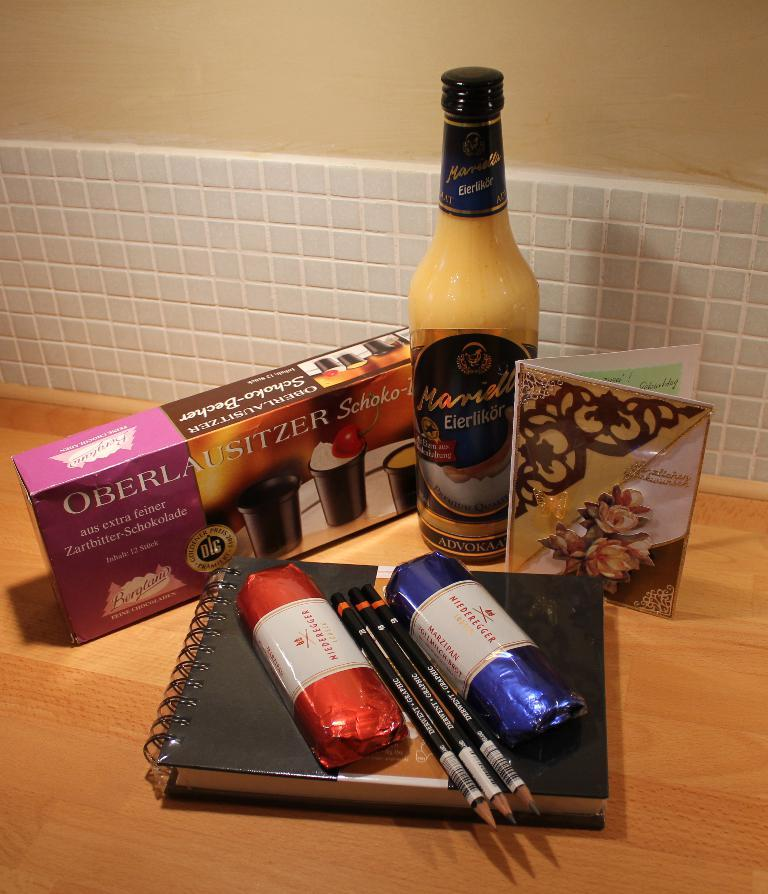<image>
Create a compact narrative representing the image presented. A box of Oberlausitzer Schoko sits next to a bottle of Eierlikor and several other items on a counter. 